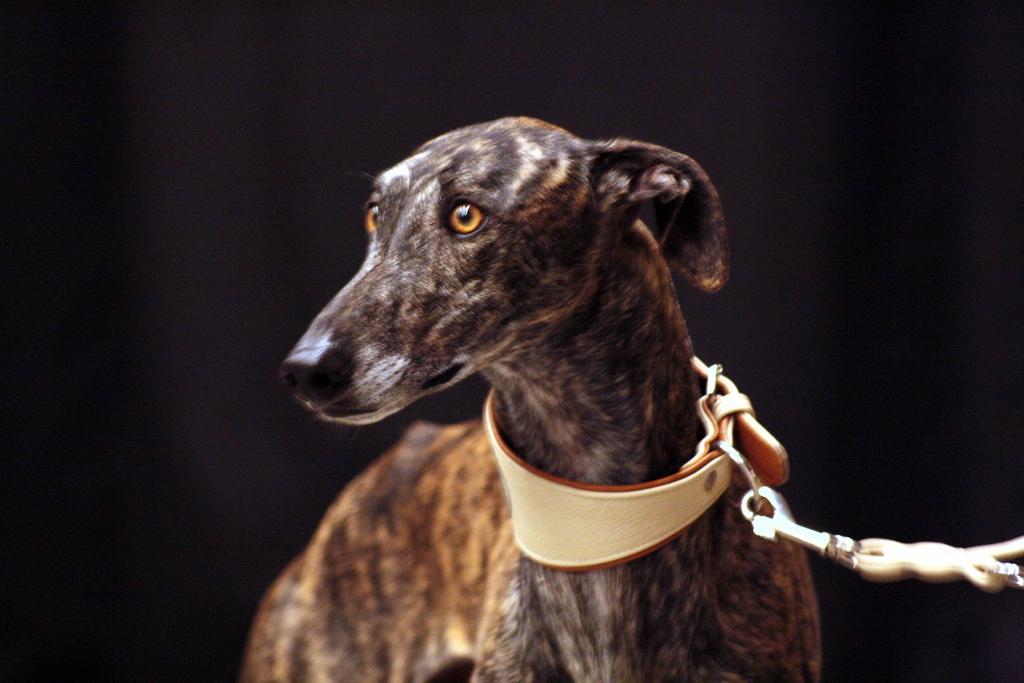Could you give a brief overview of what you see in this image? There is a black color dog, which is having a belt, which is attached to a chain. The background is dark in color. 